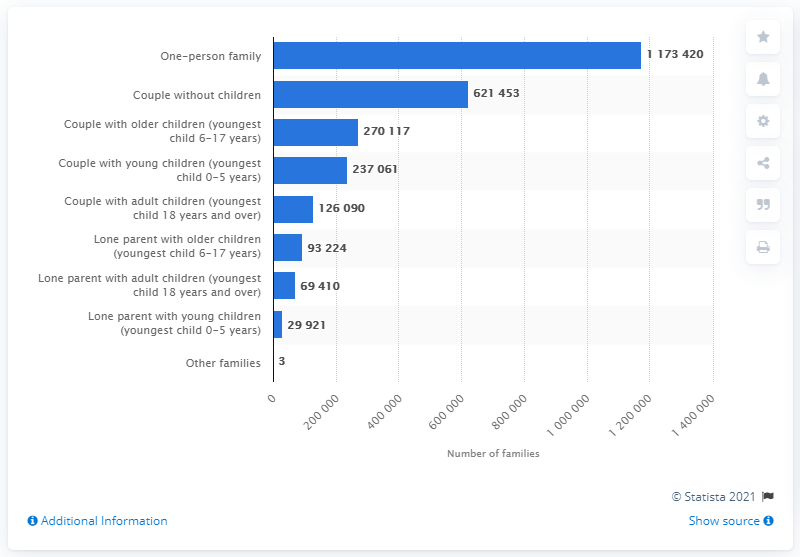List a handful of essential elements in this visual. In 2020, a total of 621,453 couples in Norway were not parents to any children. 